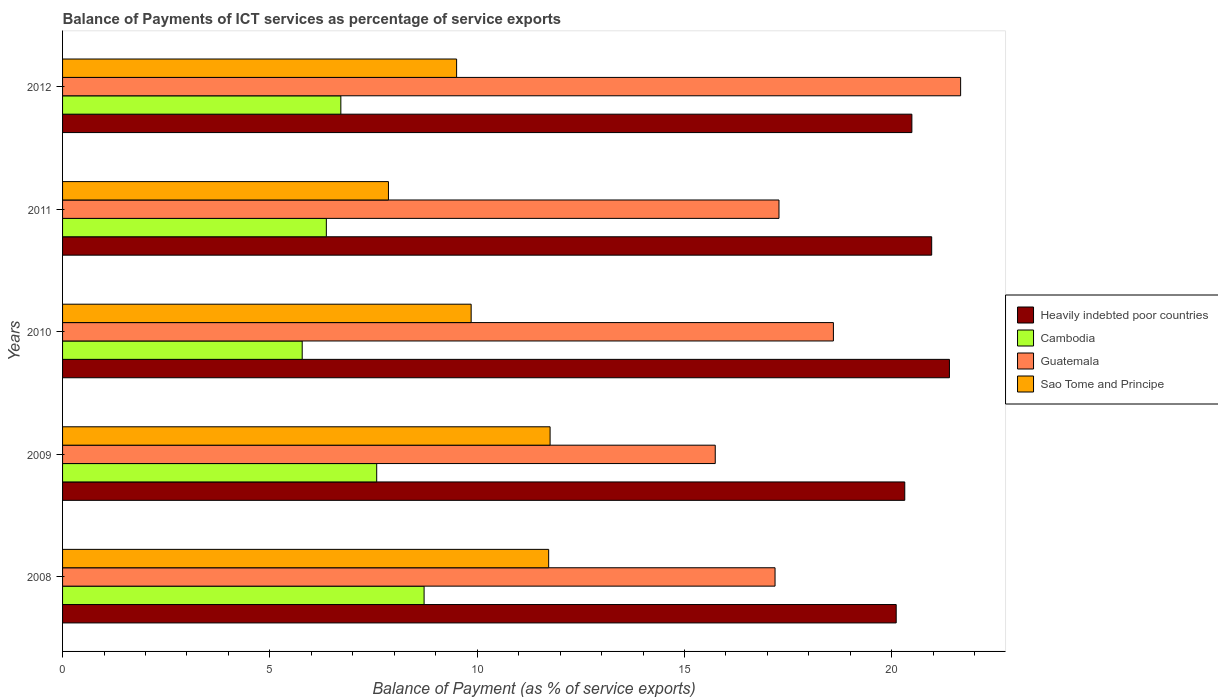How many different coloured bars are there?
Offer a terse response. 4. Are the number of bars on each tick of the Y-axis equal?
Offer a terse response. Yes. How many bars are there on the 5th tick from the bottom?
Give a very brief answer. 4. What is the label of the 5th group of bars from the top?
Ensure brevity in your answer.  2008. In how many cases, is the number of bars for a given year not equal to the number of legend labels?
Offer a terse response. 0. What is the balance of payments of ICT services in Cambodia in 2012?
Keep it short and to the point. 6.71. Across all years, what is the maximum balance of payments of ICT services in Sao Tome and Principe?
Offer a very short reply. 11.76. Across all years, what is the minimum balance of payments of ICT services in Cambodia?
Your answer should be compact. 5.78. In which year was the balance of payments of ICT services in Cambodia minimum?
Keep it short and to the point. 2010. What is the total balance of payments of ICT services in Heavily indebted poor countries in the graph?
Provide a succinct answer. 103.25. What is the difference between the balance of payments of ICT services in Guatemala in 2009 and that in 2011?
Your response must be concise. -1.54. What is the difference between the balance of payments of ICT services in Guatemala in 2009 and the balance of payments of ICT services in Cambodia in 2011?
Provide a succinct answer. 9.38. What is the average balance of payments of ICT services in Cambodia per year?
Ensure brevity in your answer.  7.03. In the year 2009, what is the difference between the balance of payments of ICT services in Heavily indebted poor countries and balance of payments of ICT services in Sao Tome and Principe?
Ensure brevity in your answer.  8.55. In how many years, is the balance of payments of ICT services in Heavily indebted poor countries greater than 1 %?
Offer a very short reply. 5. What is the ratio of the balance of payments of ICT services in Heavily indebted poor countries in 2009 to that in 2010?
Offer a terse response. 0.95. Is the balance of payments of ICT services in Sao Tome and Principe in 2008 less than that in 2010?
Provide a succinct answer. No. What is the difference between the highest and the second highest balance of payments of ICT services in Guatemala?
Keep it short and to the point. 3.07. What is the difference between the highest and the lowest balance of payments of ICT services in Heavily indebted poor countries?
Provide a short and direct response. 1.28. In how many years, is the balance of payments of ICT services in Cambodia greater than the average balance of payments of ICT services in Cambodia taken over all years?
Keep it short and to the point. 2. Is the sum of the balance of payments of ICT services in Cambodia in 2010 and 2011 greater than the maximum balance of payments of ICT services in Guatemala across all years?
Keep it short and to the point. No. What does the 2nd bar from the top in 2008 represents?
Provide a succinct answer. Guatemala. What does the 4th bar from the bottom in 2010 represents?
Provide a short and direct response. Sao Tome and Principe. Is it the case that in every year, the sum of the balance of payments of ICT services in Sao Tome and Principe and balance of payments of ICT services in Guatemala is greater than the balance of payments of ICT services in Cambodia?
Your response must be concise. Yes. How many bars are there?
Provide a short and direct response. 20. Are all the bars in the graph horizontal?
Your answer should be compact. Yes. Are the values on the major ticks of X-axis written in scientific E-notation?
Offer a terse response. No. Does the graph contain any zero values?
Your response must be concise. No. What is the title of the graph?
Your answer should be compact. Balance of Payments of ICT services as percentage of service exports. Does "East Asia (developing only)" appear as one of the legend labels in the graph?
Make the answer very short. No. What is the label or title of the X-axis?
Ensure brevity in your answer.  Balance of Payment (as % of service exports). What is the label or title of the Y-axis?
Keep it short and to the point. Years. What is the Balance of Payment (as % of service exports) in Heavily indebted poor countries in 2008?
Keep it short and to the point. 20.11. What is the Balance of Payment (as % of service exports) in Cambodia in 2008?
Provide a short and direct response. 8.72. What is the Balance of Payment (as % of service exports) of Guatemala in 2008?
Give a very brief answer. 17.18. What is the Balance of Payment (as % of service exports) of Sao Tome and Principe in 2008?
Your response must be concise. 11.72. What is the Balance of Payment (as % of service exports) in Heavily indebted poor countries in 2009?
Make the answer very short. 20.31. What is the Balance of Payment (as % of service exports) in Cambodia in 2009?
Offer a terse response. 7.58. What is the Balance of Payment (as % of service exports) in Guatemala in 2009?
Give a very brief answer. 15.74. What is the Balance of Payment (as % of service exports) of Sao Tome and Principe in 2009?
Offer a very short reply. 11.76. What is the Balance of Payment (as % of service exports) of Heavily indebted poor countries in 2010?
Offer a very short reply. 21.39. What is the Balance of Payment (as % of service exports) in Cambodia in 2010?
Provide a short and direct response. 5.78. What is the Balance of Payment (as % of service exports) of Guatemala in 2010?
Give a very brief answer. 18.59. What is the Balance of Payment (as % of service exports) in Sao Tome and Principe in 2010?
Ensure brevity in your answer.  9.85. What is the Balance of Payment (as % of service exports) of Heavily indebted poor countries in 2011?
Offer a very short reply. 20.96. What is the Balance of Payment (as % of service exports) in Cambodia in 2011?
Keep it short and to the point. 6.36. What is the Balance of Payment (as % of service exports) of Guatemala in 2011?
Offer a terse response. 17.28. What is the Balance of Payment (as % of service exports) of Sao Tome and Principe in 2011?
Offer a very short reply. 7.86. What is the Balance of Payment (as % of service exports) of Heavily indebted poor countries in 2012?
Make the answer very short. 20.48. What is the Balance of Payment (as % of service exports) of Cambodia in 2012?
Ensure brevity in your answer.  6.71. What is the Balance of Payment (as % of service exports) in Guatemala in 2012?
Your answer should be compact. 21.66. What is the Balance of Payment (as % of service exports) of Sao Tome and Principe in 2012?
Offer a terse response. 9.5. Across all years, what is the maximum Balance of Payment (as % of service exports) of Heavily indebted poor countries?
Make the answer very short. 21.39. Across all years, what is the maximum Balance of Payment (as % of service exports) of Cambodia?
Provide a succinct answer. 8.72. Across all years, what is the maximum Balance of Payment (as % of service exports) of Guatemala?
Keep it short and to the point. 21.66. Across all years, what is the maximum Balance of Payment (as % of service exports) of Sao Tome and Principe?
Offer a terse response. 11.76. Across all years, what is the minimum Balance of Payment (as % of service exports) of Heavily indebted poor countries?
Keep it short and to the point. 20.11. Across all years, what is the minimum Balance of Payment (as % of service exports) in Cambodia?
Ensure brevity in your answer.  5.78. Across all years, what is the minimum Balance of Payment (as % of service exports) of Guatemala?
Your answer should be compact. 15.74. Across all years, what is the minimum Balance of Payment (as % of service exports) in Sao Tome and Principe?
Keep it short and to the point. 7.86. What is the total Balance of Payment (as % of service exports) of Heavily indebted poor countries in the graph?
Your answer should be very brief. 103.25. What is the total Balance of Payment (as % of service exports) in Cambodia in the graph?
Offer a terse response. 35.15. What is the total Balance of Payment (as % of service exports) in Guatemala in the graph?
Keep it short and to the point. 90.45. What is the total Balance of Payment (as % of service exports) in Sao Tome and Principe in the graph?
Offer a very short reply. 50.7. What is the difference between the Balance of Payment (as % of service exports) in Heavily indebted poor countries in 2008 and that in 2009?
Make the answer very short. -0.21. What is the difference between the Balance of Payment (as % of service exports) in Cambodia in 2008 and that in 2009?
Make the answer very short. 1.14. What is the difference between the Balance of Payment (as % of service exports) of Guatemala in 2008 and that in 2009?
Provide a short and direct response. 1.44. What is the difference between the Balance of Payment (as % of service exports) of Sao Tome and Principe in 2008 and that in 2009?
Make the answer very short. -0.03. What is the difference between the Balance of Payment (as % of service exports) of Heavily indebted poor countries in 2008 and that in 2010?
Make the answer very short. -1.28. What is the difference between the Balance of Payment (as % of service exports) in Cambodia in 2008 and that in 2010?
Ensure brevity in your answer.  2.94. What is the difference between the Balance of Payment (as % of service exports) in Guatemala in 2008 and that in 2010?
Your answer should be very brief. -1.41. What is the difference between the Balance of Payment (as % of service exports) of Sao Tome and Principe in 2008 and that in 2010?
Offer a very short reply. 1.87. What is the difference between the Balance of Payment (as % of service exports) of Heavily indebted poor countries in 2008 and that in 2011?
Give a very brief answer. -0.86. What is the difference between the Balance of Payment (as % of service exports) of Cambodia in 2008 and that in 2011?
Your answer should be very brief. 2.36. What is the difference between the Balance of Payment (as % of service exports) of Guatemala in 2008 and that in 2011?
Keep it short and to the point. -0.09. What is the difference between the Balance of Payment (as % of service exports) of Sao Tome and Principe in 2008 and that in 2011?
Keep it short and to the point. 3.86. What is the difference between the Balance of Payment (as % of service exports) of Heavily indebted poor countries in 2008 and that in 2012?
Offer a terse response. -0.38. What is the difference between the Balance of Payment (as % of service exports) of Cambodia in 2008 and that in 2012?
Ensure brevity in your answer.  2.01. What is the difference between the Balance of Payment (as % of service exports) of Guatemala in 2008 and that in 2012?
Your answer should be compact. -4.48. What is the difference between the Balance of Payment (as % of service exports) of Sao Tome and Principe in 2008 and that in 2012?
Your answer should be compact. 2.22. What is the difference between the Balance of Payment (as % of service exports) in Heavily indebted poor countries in 2009 and that in 2010?
Your response must be concise. -1.08. What is the difference between the Balance of Payment (as % of service exports) in Cambodia in 2009 and that in 2010?
Make the answer very short. 1.8. What is the difference between the Balance of Payment (as % of service exports) in Guatemala in 2009 and that in 2010?
Ensure brevity in your answer.  -2.85. What is the difference between the Balance of Payment (as % of service exports) in Sao Tome and Principe in 2009 and that in 2010?
Provide a succinct answer. 1.9. What is the difference between the Balance of Payment (as % of service exports) in Heavily indebted poor countries in 2009 and that in 2011?
Provide a succinct answer. -0.65. What is the difference between the Balance of Payment (as % of service exports) in Cambodia in 2009 and that in 2011?
Ensure brevity in your answer.  1.21. What is the difference between the Balance of Payment (as % of service exports) of Guatemala in 2009 and that in 2011?
Ensure brevity in your answer.  -1.54. What is the difference between the Balance of Payment (as % of service exports) of Sao Tome and Principe in 2009 and that in 2011?
Your answer should be very brief. 3.9. What is the difference between the Balance of Payment (as % of service exports) in Heavily indebted poor countries in 2009 and that in 2012?
Ensure brevity in your answer.  -0.17. What is the difference between the Balance of Payment (as % of service exports) of Cambodia in 2009 and that in 2012?
Your answer should be very brief. 0.86. What is the difference between the Balance of Payment (as % of service exports) of Guatemala in 2009 and that in 2012?
Your answer should be compact. -5.92. What is the difference between the Balance of Payment (as % of service exports) in Sao Tome and Principe in 2009 and that in 2012?
Offer a terse response. 2.25. What is the difference between the Balance of Payment (as % of service exports) in Heavily indebted poor countries in 2010 and that in 2011?
Ensure brevity in your answer.  0.43. What is the difference between the Balance of Payment (as % of service exports) in Cambodia in 2010 and that in 2011?
Provide a succinct answer. -0.58. What is the difference between the Balance of Payment (as % of service exports) in Guatemala in 2010 and that in 2011?
Your answer should be very brief. 1.31. What is the difference between the Balance of Payment (as % of service exports) of Sao Tome and Principe in 2010 and that in 2011?
Your answer should be very brief. 1.99. What is the difference between the Balance of Payment (as % of service exports) in Heavily indebted poor countries in 2010 and that in 2012?
Keep it short and to the point. 0.91. What is the difference between the Balance of Payment (as % of service exports) in Cambodia in 2010 and that in 2012?
Offer a terse response. -0.93. What is the difference between the Balance of Payment (as % of service exports) in Guatemala in 2010 and that in 2012?
Offer a very short reply. -3.07. What is the difference between the Balance of Payment (as % of service exports) of Sao Tome and Principe in 2010 and that in 2012?
Provide a short and direct response. 0.35. What is the difference between the Balance of Payment (as % of service exports) in Heavily indebted poor countries in 2011 and that in 2012?
Your answer should be very brief. 0.48. What is the difference between the Balance of Payment (as % of service exports) of Cambodia in 2011 and that in 2012?
Your answer should be compact. -0.35. What is the difference between the Balance of Payment (as % of service exports) of Guatemala in 2011 and that in 2012?
Your response must be concise. -4.38. What is the difference between the Balance of Payment (as % of service exports) in Sao Tome and Principe in 2011 and that in 2012?
Provide a short and direct response. -1.64. What is the difference between the Balance of Payment (as % of service exports) of Heavily indebted poor countries in 2008 and the Balance of Payment (as % of service exports) of Cambodia in 2009?
Offer a terse response. 12.53. What is the difference between the Balance of Payment (as % of service exports) of Heavily indebted poor countries in 2008 and the Balance of Payment (as % of service exports) of Guatemala in 2009?
Provide a succinct answer. 4.36. What is the difference between the Balance of Payment (as % of service exports) in Heavily indebted poor countries in 2008 and the Balance of Payment (as % of service exports) in Sao Tome and Principe in 2009?
Keep it short and to the point. 8.35. What is the difference between the Balance of Payment (as % of service exports) in Cambodia in 2008 and the Balance of Payment (as % of service exports) in Guatemala in 2009?
Make the answer very short. -7.02. What is the difference between the Balance of Payment (as % of service exports) in Cambodia in 2008 and the Balance of Payment (as % of service exports) in Sao Tome and Principe in 2009?
Give a very brief answer. -3.04. What is the difference between the Balance of Payment (as % of service exports) in Guatemala in 2008 and the Balance of Payment (as % of service exports) in Sao Tome and Principe in 2009?
Make the answer very short. 5.43. What is the difference between the Balance of Payment (as % of service exports) in Heavily indebted poor countries in 2008 and the Balance of Payment (as % of service exports) in Cambodia in 2010?
Provide a succinct answer. 14.33. What is the difference between the Balance of Payment (as % of service exports) of Heavily indebted poor countries in 2008 and the Balance of Payment (as % of service exports) of Guatemala in 2010?
Provide a short and direct response. 1.51. What is the difference between the Balance of Payment (as % of service exports) in Heavily indebted poor countries in 2008 and the Balance of Payment (as % of service exports) in Sao Tome and Principe in 2010?
Provide a succinct answer. 10.25. What is the difference between the Balance of Payment (as % of service exports) of Cambodia in 2008 and the Balance of Payment (as % of service exports) of Guatemala in 2010?
Give a very brief answer. -9.87. What is the difference between the Balance of Payment (as % of service exports) of Cambodia in 2008 and the Balance of Payment (as % of service exports) of Sao Tome and Principe in 2010?
Your answer should be compact. -1.14. What is the difference between the Balance of Payment (as % of service exports) of Guatemala in 2008 and the Balance of Payment (as % of service exports) of Sao Tome and Principe in 2010?
Provide a short and direct response. 7.33. What is the difference between the Balance of Payment (as % of service exports) in Heavily indebted poor countries in 2008 and the Balance of Payment (as % of service exports) in Cambodia in 2011?
Offer a terse response. 13.74. What is the difference between the Balance of Payment (as % of service exports) of Heavily indebted poor countries in 2008 and the Balance of Payment (as % of service exports) of Guatemala in 2011?
Your answer should be very brief. 2.83. What is the difference between the Balance of Payment (as % of service exports) of Heavily indebted poor countries in 2008 and the Balance of Payment (as % of service exports) of Sao Tome and Principe in 2011?
Your response must be concise. 12.25. What is the difference between the Balance of Payment (as % of service exports) in Cambodia in 2008 and the Balance of Payment (as % of service exports) in Guatemala in 2011?
Offer a terse response. -8.56. What is the difference between the Balance of Payment (as % of service exports) in Cambodia in 2008 and the Balance of Payment (as % of service exports) in Sao Tome and Principe in 2011?
Your answer should be compact. 0.86. What is the difference between the Balance of Payment (as % of service exports) in Guatemala in 2008 and the Balance of Payment (as % of service exports) in Sao Tome and Principe in 2011?
Offer a very short reply. 9.32. What is the difference between the Balance of Payment (as % of service exports) in Heavily indebted poor countries in 2008 and the Balance of Payment (as % of service exports) in Cambodia in 2012?
Make the answer very short. 13.39. What is the difference between the Balance of Payment (as % of service exports) of Heavily indebted poor countries in 2008 and the Balance of Payment (as % of service exports) of Guatemala in 2012?
Provide a succinct answer. -1.55. What is the difference between the Balance of Payment (as % of service exports) of Heavily indebted poor countries in 2008 and the Balance of Payment (as % of service exports) of Sao Tome and Principe in 2012?
Give a very brief answer. 10.6. What is the difference between the Balance of Payment (as % of service exports) of Cambodia in 2008 and the Balance of Payment (as % of service exports) of Guatemala in 2012?
Your answer should be compact. -12.94. What is the difference between the Balance of Payment (as % of service exports) in Cambodia in 2008 and the Balance of Payment (as % of service exports) in Sao Tome and Principe in 2012?
Keep it short and to the point. -0.78. What is the difference between the Balance of Payment (as % of service exports) in Guatemala in 2008 and the Balance of Payment (as % of service exports) in Sao Tome and Principe in 2012?
Offer a very short reply. 7.68. What is the difference between the Balance of Payment (as % of service exports) of Heavily indebted poor countries in 2009 and the Balance of Payment (as % of service exports) of Cambodia in 2010?
Offer a very short reply. 14.53. What is the difference between the Balance of Payment (as % of service exports) in Heavily indebted poor countries in 2009 and the Balance of Payment (as % of service exports) in Guatemala in 2010?
Give a very brief answer. 1.72. What is the difference between the Balance of Payment (as % of service exports) of Heavily indebted poor countries in 2009 and the Balance of Payment (as % of service exports) of Sao Tome and Principe in 2010?
Make the answer very short. 10.46. What is the difference between the Balance of Payment (as % of service exports) of Cambodia in 2009 and the Balance of Payment (as % of service exports) of Guatemala in 2010?
Offer a terse response. -11.02. What is the difference between the Balance of Payment (as % of service exports) in Cambodia in 2009 and the Balance of Payment (as % of service exports) in Sao Tome and Principe in 2010?
Keep it short and to the point. -2.28. What is the difference between the Balance of Payment (as % of service exports) in Guatemala in 2009 and the Balance of Payment (as % of service exports) in Sao Tome and Principe in 2010?
Your response must be concise. 5.89. What is the difference between the Balance of Payment (as % of service exports) in Heavily indebted poor countries in 2009 and the Balance of Payment (as % of service exports) in Cambodia in 2011?
Provide a short and direct response. 13.95. What is the difference between the Balance of Payment (as % of service exports) in Heavily indebted poor countries in 2009 and the Balance of Payment (as % of service exports) in Guatemala in 2011?
Your answer should be compact. 3.03. What is the difference between the Balance of Payment (as % of service exports) of Heavily indebted poor countries in 2009 and the Balance of Payment (as % of service exports) of Sao Tome and Principe in 2011?
Your answer should be compact. 12.45. What is the difference between the Balance of Payment (as % of service exports) of Cambodia in 2009 and the Balance of Payment (as % of service exports) of Guatemala in 2011?
Your answer should be very brief. -9.7. What is the difference between the Balance of Payment (as % of service exports) of Cambodia in 2009 and the Balance of Payment (as % of service exports) of Sao Tome and Principe in 2011?
Keep it short and to the point. -0.28. What is the difference between the Balance of Payment (as % of service exports) in Guatemala in 2009 and the Balance of Payment (as % of service exports) in Sao Tome and Principe in 2011?
Ensure brevity in your answer.  7.88. What is the difference between the Balance of Payment (as % of service exports) in Heavily indebted poor countries in 2009 and the Balance of Payment (as % of service exports) in Cambodia in 2012?
Ensure brevity in your answer.  13.6. What is the difference between the Balance of Payment (as % of service exports) in Heavily indebted poor countries in 2009 and the Balance of Payment (as % of service exports) in Guatemala in 2012?
Ensure brevity in your answer.  -1.35. What is the difference between the Balance of Payment (as % of service exports) in Heavily indebted poor countries in 2009 and the Balance of Payment (as % of service exports) in Sao Tome and Principe in 2012?
Your answer should be compact. 10.81. What is the difference between the Balance of Payment (as % of service exports) of Cambodia in 2009 and the Balance of Payment (as % of service exports) of Guatemala in 2012?
Offer a very short reply. -14.08. What is the difference between the Balance of Payment (as % of service exports) of Cambodia in 2009 and the Balance of Payment (as % of service exports) of Sao Tome and Principe in 2012?
Offer a very short reply. -1.93. What is the difference between the Balance of Payment (as % of service exports) of Guatemala in 2009 and the Balance of Payment (as % of service exports) of Sao Tome and Principe in 2012?
Your answer should be very brief. 6.24. What is the difference between the Balance of Payment (as % of service exports) in Heavily indebted poor countries in 2010 and the Balance of Payment (as % of service exports) in Cambodia in 2011?
Offer a very short reply. 15.03. What is the difference between the Balance of Payment (as % of service exports) of Heavily indebted poor countries in 2010 and the Balance of Payment (as % of service exports) of Guatemala in 2011?
Your answer should be compact. 4.11. What is the difference between the Balance of Payment (as % of service exports) in Heavily indebted poor countries in 2010 and the Balance of Payment (as % of service exports) in Sao Tome and Principe in 2011?
Offer a terse response. 13.53. What is the difference between the Balance of Payment (as % of service exports) in Cambodia in 2010 and the Balance of Payment (as % of service exports) in Guatemala in 2011?
Give a very brief answer. -11.5. What is the difference between the Balance of Payment (as % of service exports) of Cambodia in 2010 and the Balance of Payment (as % of service exports) of Sao Tome and Principe in 2011?
Provide a succinct answer. -2.08. What is the difference between the Balance of Payment (as % of service exports) of Guatemala in 2010 and the Balance of Payment (as % of service exports) of Sao Tome and Principe in 2011?
Keep it short and to the point. 10.73. What is the difference between the Balance of Payment (as % of service exports) in Heavily indebted poor countries in 2010 and the Balance of Payment (as % of service exports) in Cambodia in 2012?
Ensure brevity in your answer.  14.68. What is the difference between the Balance of Payment (as % of service exports) of Heavily indebted poor countries in 2010 and the Balance of Payment (as % of service exports) of Guatemala in 2012?
Provide a succinct answer. -0.27. What is the difference between the Balance of Payment (as % of service exports) of Heavily indebted poor countries in 2010 and the Balance of Payment (as % of service exports) of Sao Tome and Principe in 2012?
Provide a short and direct response. 11.89. What is the difference between the Balance of Payment (as % of service exports) of Cambodia in 2010 and the Balance of Payment (as % of service exports) of Guatemala in 2012?
Give a very brief answer. -15.88. What is the difference between the Balance of Payment (as % of service exports) in Cambodia in 2010 and the Balance of Payment (as % of service exports) in Sao Tome and Principe in 2012?
Offer a very short reply. -3.72. What is the difference between the Balance of Payment (as % of service exports) of Guatemala in 2010 and the Balance of Payment (as % of service exports) of Sao Tome and Principe in 2012?
Provide a succinct answer. 9.09. What is the difference between the Balance of Payment (as % of service exports) of Heavily indebted poor countries in 2011 and the Balance of Payment (as % of service exports) of Cambodia in 2012?
Give a very brief answer. 14.25. What is the difference between the Balance of Payment (as % of service exports) in Heavily indebted poor countries in 2011 and the Balance of Payment (as % of service exports) in Guatemala in 2012?
Keep it short and to the point. -0.7. What is the difference between the Balance of Payment (as % of service exports) of Heavily indebted poor countries in 2011 and the Balance of Payment (as % of service exports) of Sao Tome and Principe in 2012?
Your answer should be very brief. 11.46. What is the difference between the Balance of Payment (as % of service exports) in Cambodia in 2011 and the Balance of Payment (as % of service exports) in Guatemala in 2012?
Make the answer very short. -15.3. What is the difference between the Balance of Payment (as % of service exports) in Cambodia in 2011 and the Balance of Payment (as % of service exports) in Sao Tome and Principe in 2012?
Your answer should be compact. -3.14. What is the difference between the Balance of Payment (as % of service exports) of Guatemala in 2011 and the Balance of Payment (as % of service exports) of Sao Tome and Principe in 2012?
Your answer should be very brief. 7.77. What is the average Balance of Payment (as % of service exports) in Heavily indebted poor countries per year?
Give a very brief answer. 20.65. What is the average Balance of Payment (as % of service exports) of Cambodia per year?
Keep it short and to the point. 7.03. What is the average Balance of Payment (as % of service exports) of Guatemala per year?
Make the answer very short. 18.09. What is the average Balance of Payment (as % of service exports) of Sao Tome and Principe per year?
Your answer should be very brief. 10.14. In the year 2008, what is the difference between the Balance of Payment (as % of service exports) of Heavily indebted poor countries and Balance of Payment (as % of service exports) of Cambodia?
Provide a succinct answer. 11.39. In the year 2008, what is the difference between the Balance of Payment (as % of service exports) in Heavily indebted poor countries and Balance of Payment (as % of service exports) in Guatemala?
Keep it short and to the point. 2.92. In the year 2008, what is the difference between the Balance of Payment (as % of service exports) of Heavily indebted poor countries and Balance of Payment (as % of service exports) of Sao Tome and Principe?
Give a very brief answer. 8.38. In the year 2008, what is the difference between the Balance of Payment (as % of service exports) of Cambodia and Balance of Payment (as % of service exports) of Guatemala?
Keep it short and to the point. -8.46. In the year 2008, what is the difference between the Balance of Payment (as % of service exports) of Cambodia and Balance of Payment (as % of service exports) of Sao Tome and Principe?
Make the answer very short. -3. In the year 2008, what is the difference between the Balance of Payment (as % of service exports) of Guatemala and Balance of Payment (as % of service exports) of Sao Tome and Principe?
Offer a terse response. 5.46. In the year 2009, what is the difference between the Balance of Payment (as % of service exports) in Heavily indebted poor countries and Balance of Payment (as % of service exports) in Cambodia?
Your response must be concise. 12.74. In the year 2009, what is the difference between the Balance of Payment (as % of service exports) in Heavily indebted poor countries and Balance of Payment (as % of service exports) in Guatemala?
Your answer should be very brief. 4.57. In the year 2009, what is the difference between the Balance of Payment (as % of service exports) of Heavily indebted poor countries and Balance of Payment (as % of service exports) of Sao Tome and Principe?
Your answer should be very brief. 8.55. In the year 2009, what is the difference between the Balance of Payment (as % of service exports) in Cambodia and Balance of Payment (as % of service exports) in Guatemala?
Provide a short and direct response. -8.17. In the year 2009, what is the difference between the Balance of Payment (as % of service exports) in Cambodia and Balance of Payment (as % of service exports) in Sao Tome and Principe?
Provide a succinct answer. -4.18. In the year 2009, what is the difference between the Balance of Payment (as % of service exports) in Guatemala and Balance of Payment (as % of service exports) in Sao Tome and Principe?
Your answer should be very brief. 3.98. In the year 2010, what is the difference between the Balance of Payment (as % of service exports) of Heavily indebted poor countries and Balance of Payment (as % of service exports) of Cambodia?
Your answer should be compact. 15.61. In the year 2010, what is the difference between the Balance of Payment (as % of service exports) of Heavily indebted poor countries and Balance of Payment (as % of service exports) of Guatemala?
Make the answer very short. 2.8. In the year 2010, what is the difference between the Balance of Payment (as % of service exports) in Heavily indebted poor countries and Balance of Payment (as % of service exports) in Sao Tome and Principe?
Keep it short and to the point. 11.54. In the year 2010, what is the difference between the Balance of Payment (as % of service exports) of Cambodia and Balance of Payment (as % of service exports) of Guatemala?
Provide a short and direct response. -12.81. In the year 2010, what is the difference between the Balance of Payment (as % of service exports) in Cambodia and Balance of Payment (as % of service exports) in Sao Tome and Principe?
Your response must be concise. -4.07. In the year 2010, what is the difference between the Balance of Payment (as % of service exports) in Guatemala and Balance of Payment (as % of service exports) in Sao Tome and Principe?
Your answer should be very brief. 8.74. In the year 2011, what is the difference between the Balance of Payment (as % of service exports) of Heavily indebted poor countries and Balance of Payment (as % of service exports) of Cambodia?
Give a very brief answer. 14.6. In the year 2011, what is the difference between the Balance of Payment (as % of service exports) in Heavily indebted poor countries and Balance of Payment (as % of service exports) in Guatemala?
Offer a terse response. 3.68. In the year 2011, what is the difference between the Balance of Payment (as % of service exports) in Heavily indebted poor countries and Balance of Payment (as % of service exports) in Sao Tome and Principe?
Provide a short and direct response. 13.1. In the year 2011, what is the difference between the Balance of Payment (as % of service exports) in Cambodia and Balance of Payment (as % of service exports) in Guatemala?
Keep it short and to the point. -10.92. In the year 2011, what is the difference between the Balance of Payment (as % of service exports) in Cambodia and Balance of Payment (as % of service exports) in Sao Tome and Principe?
Offer a very short reply. -1.5. In the year 2011, what is the difference between the Balance of Payment (as % of service exports) of Guatemala and Balance of Payment (as % of service exports) of Sao Tome and Principe?
Ensure brevity in your answer.  9.42. In the year 2012, what is the difference between the Balance of Payment (as % of service exports) of Heavily indebted poor countries and Balance of Payment (as % of service exports) of Cambodia?
Offer a terse response. 13.77. In the year 2012, what is the difference between the Balance of Payment (as % of service exports) of Heavily indebted poor countries and Balance of Payment (as % of service exports) of Guatemala?
Your answer should be compact. -1.18. In the year 2012, what is the difference between the Balance of Payment (as % of service exports) in Heavily indebted poor countries and Balance of Payment (as % of service exports) in Sao Tome and Principe?
Provide a succinct answer. 10.98. In the year 2012, what is the difference between the Balance of Payment (as % of service exports) in Cambodia and Balance of Payment (as % of service exports) in Guatemala?
Provide a succinct answer. -14.95. In the year 2012, what is the difference between the Balance of Payment (as % of service exports) in Cambodia and Balance of Payment (as % of service exports) in Sao Tome and Principe?
Provide a short and direct response. -2.79. In the year 2012, what is the difference between the Balance of Payment (as % of service exports) in Guatemala and Balance of Payment (as % of service exports) in Sao Tome and Principe?
Offer a terse response. 12.16. What is the ratio of the Balance of Payment (as % of service exports) of Cambodia in 2008 to that in 2009?
Keep it short and to the point. 1.15. What is the ratio of the Balance of Payment (as % of service exports) of Guatemala in 2008 to that in 2009?
Offer a terse response. 1.09. What is the ratio of the Balance of Payment (as % of service exports) of Heavily indebted poor countries in 2008 to that in 2010?
Give a very brief answer. 0.94. What is the ratio of the Balance of Payment (as % of service exports) of Cambodia in 2008 to that in 2010?
Provide a short and direct response. 1.51. What is the ratio of the Balance of Payment (as % of service exports) in Guatemala in 2008 to that in 2010?
Your response must be concise. 0.92. What is the ratio of the Balance of Payment (as % of service exports) of Sao Tome and Principe in 2008 to that in 2010?
Your answer should be very brief. 1.19. What is the ratio of the Balance of Payment (as % of service exports) of Heavily indebted poor countries in 2008 to that in 2011?
Give a very brief answer. 0.96. What is the ratio of the Balance of Payment (as % of service exports) of Cambodia in 2008 to that in 2011?
Ensure brevity in your answer.  1.37. What is the ratio of the Balance of Payment (as % of service exports) in Guatemala in 2008 to that in 2011?
Your response must be concise. 0.99. What is the ratio of the Balance of Payment (as % of service exports) of Sao Tome and Principe in 2008 to that in 2011?
Your answer should be compact. 1.49. What is the ratio of the Balance of Payment (as % of service exports) in Heavily indebted poor countries in 2008 to that in 2012?
Your answer should be compact. 0.98. What is the ratio of the Balance of Payment (as % of service exports) of Cambodia in 2008 to that in 2012?
Your answer should be very brief. 1.3. What is the ratio of the Balance of Payment (as % of service exports) in Guatemala in 2008 to that in 2012?
Ensure brevity in your answer.  0.79. What is the ratio of the Balance of Payment (as % of service exports) in Sao Tome and Principe in 2008 to that in 2012?
Your response must be concise. 1.23. What is the ratio of the Balance of Payment (as % of service exports) in Heavily indebted poor countries in 2009 to that in 2010?
Provide a short and direct response. 0.95. What is the ratio of the Balance of Payment (as % of service exports) of Cambodia in 2009 to that in 2010?
Make the answer very short. 1.31. What is the ratio of the Balance of Payment (as % of service exports) in Guatemala in 2009 to that in 2010?
Provide a short and direct response. 0.85. What is the ratio of the Balance of Payment (as % of service exports) in Sao Tome and Principe in 2009 to that in 2010?
Make the answer very short. 1.19. What is the ratio of the Balance of Payment (as % of service exports) of Heavily indebted poor countries in 2009 to that in 2011?
Ensure brevity in your answer.  0.97. What is the ratio of the Balance of Payment (as % of service exports) in Cambodia in 2009 to that in 2011?
Make the answer very short. 1.19. What is the ratio of the Balance of Payment (as % of service exports) of Guatemala in 2009 to that in 2011?
Your response must be concise. 0.91. What is the ratio of the Balance of Payment (as % of service exports) in Sao Tome and Principe in 2009 to that in 2011?
Keep it short and to the point. 1.5. What is the ratio of the Balance of Payment (as % of service exports) in Heavily indebted poor countries in 2009 to that in 2012?
Make the answer very short. 0.99. What is the ratio of the Balance of Payment (as % of service exports) in Cambodia in 2009 to that in 2012?
Keep it short and to the point. 1.13. What is the ratio of the Balance of Payment (as % of service exports) in Guatemala in 2009 to that in 2012?
Give a very brief answer. 0.73. What is the ratio of the Balance of Payment (as % of service exports) of Sao Tome and Principe in 2009 to that in 2012?
Keep it short and to the point. 1.24. What is the ratio of the Balance of Payment (as % of service exports) in Heavily indebted poor countries in 2010 to that in 2011?
Your answer should be very brief. 1.02. What is the ratio of the Balance of Payment (as % of service exports) of Cambodia in 2010 to that in 2011?
Your answer should be compact. 0.91. What is the ratio of the Balance of Payment (as % of service exports) in Guatemala in 2010 to that in 2011?
Your response must be concise. 1.08. What is the ratio of the Balance of Payment (as % of service exports) of Sao Tome and Principe in 2010 to that in 2011?
Keep it short and to the point. 1.25. What is the ratio of the Balance of Payment (as % of service exports) in Heavily indebted poor countries in 2010 to that in 2012?
Your response must be concise. 1.04. What is the ratio of the Balance of Payment (as % of service exports) of Cambodia in 2010 to that in 2012?
Give a very brief answer. 0.86. What is the ratio of the Balance of Payment (as % of service exports) in Guatemala in 2010 to that in 2012?
Provide a succinct answer. 0.86. What is the ratio of the Balance of Payment (as % of service exports) of Sao Tome and Principe in 2010 to that in 2012?
Your answer should be compact. 1.04. What is the ratio of the Balance of Payment (as % of service exports) of Heavily indebted poor countries in 2011 to that in 2012?
Your answer should be very brief. 1.02. What is the ratio of the Balance of Payment (as % of service exports) in Cambodia in 2011 to that in 2012?
Provide a succinct answer. 0.95. What is the ratio of the Balance of Payment (as % of service exports) of Guatemala in 2011 to that in 2012?
Provide a succinct answer. 0.8. What is the ratio of the Balance of Payment (as % of service exports) of Sao Tome and Principe in 2011 to that in 2012?
Offer a very short reply. 0.83. What is the difference between the highest and the second highest Balance of Payment (as % of service exports) in Heavily indebted poor countries?
Make the answer very short. 0.43. What is the difference between the highest and the second highest Balance of Payment (as % of service exports) of Cambodia?
Make the answer very short. 1.14. What is the difference between the highest and the second highest Balance of Payment (as % of service exports) of Guatemala?
Offer a terse response. 3.07. What is the difference between the highest and the second highest Balance of Payment (as % of service exports) of Sao Tome and Principe?
Provide a succinct answer. 0.03. What is the difference between the highest and the lowest Balance of Payment (as % of service exports) of Heavily indebted poor countries?
Make the answer very short. 1.28. What is the difference between the highest and the lowest Balance of Payment (as % of service exports) of Cambodia?
Provide a short and direct response. 2.94. What is the difference between the highest and the lowest Balance of Payment (as % of service exports) in Guatemala?
Offer a terse response. 5.92. What is the difference between the highest and the lowest Balance of Payment (as % of service exports) in Sao Tome and Principe?
Ensure brevity in your answer.  3.9. 